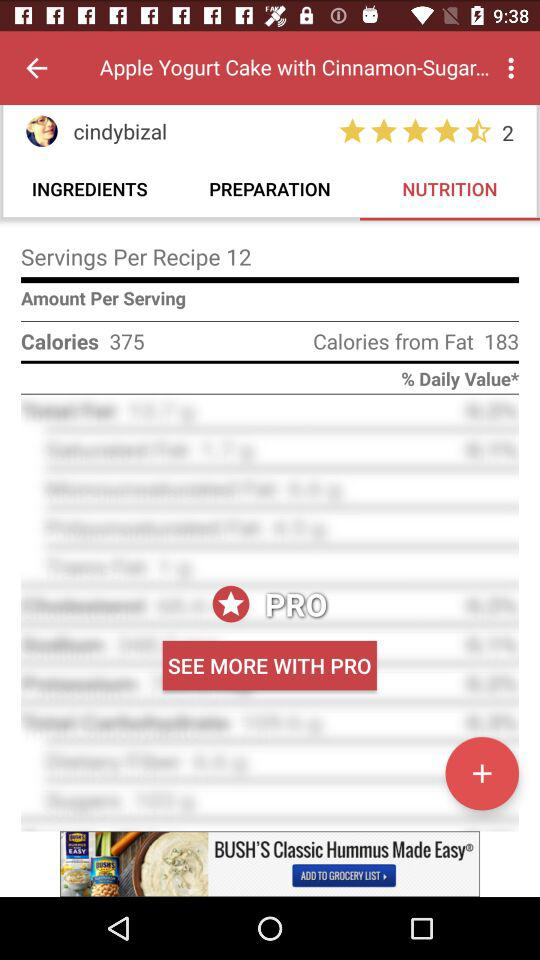How many calories are in one serving of this recipe?
Answer the question using a single word or phrase. 375 